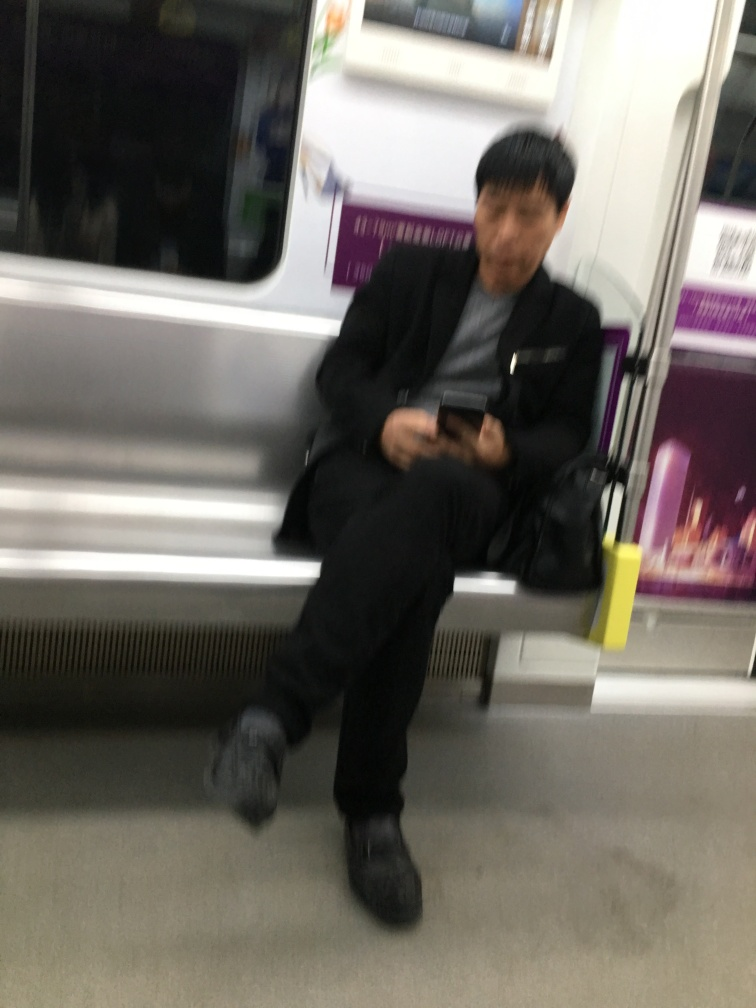Are there any quality issues with this image? Yes, the image is blurred which reduces the clarity and detail that can be discerned, making it difficult to fully appreciate the content. Additionally, it appears to be taken in low lighting conditions which can further degrade the photo quality. 